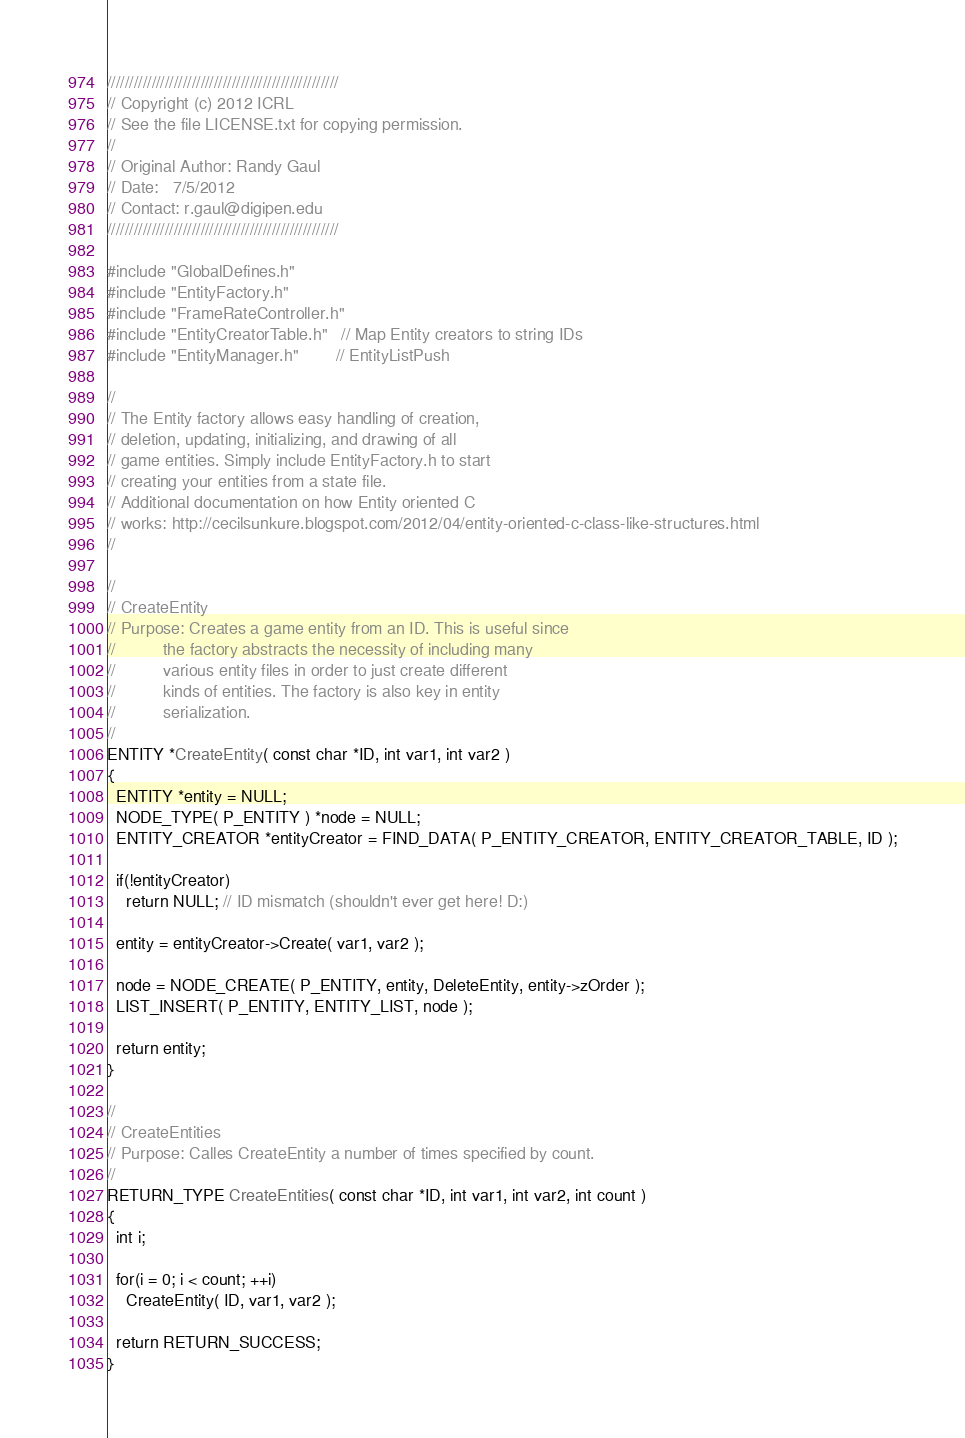Convert code to text. <code><loc_0><loc_0><loc_500><loc_500><_C_>////////////////////////////////////////////////////
// Copyright (c) 2012 ICRL
// See the file LICENSE.txt for copying permission.
// 
// Original Author: Randy Gaul
// Date:   7/5/2012
// Contact: r.gaul@digipen.edu
////////////////////////////////////////////////////

#include "GlobalDefines.h"
#include "EntityFactory.h"
#include "FrameRateController.h"
#include "EntityCreatorTable.h"   // Map Entity creators to string IDs
#include "EntityManager.h"        // EntityListPush

//
// The Entity factory allows easy handling of creation,
// deletion, updating, initializing, and drawing of all
// game entities. Simply include EntityFactory.h to start
// creating your entities from a state file.
// Additional documentation on how Entity oriented C
// works: http://cecilsunkure.blogspot.com/2012/04/entity-oriented-c-class-like-structures.html
//

//
// CreateEntity
// Purpose: Creates a game entity from an ID. This is useful since
//          the factory abstracts the necessity of including many
//          various entity files in order to just create different
//          kinds of entities. The factory is also key in entity
//          serialization.
//
ENTITY *CreateEntity( const char *ID, int var1, int var2 )
{
  ENTITY *entity = NULL;
  NODE_TYPE( P_ENTITY ) *node = NULL;
  ENTITY_CREATOR *entityCreator = FIND_DATA( P_ENTITY_CREATOR, ENTITY_CREATOR_TABLE, ID );

  if(!entityCreator)
    return NULL; // ID mismatch (shouldn't ever get here! D:)

  entity = entityCreator->Create( var1, var2 );

  node = NODE_CREATE( P_ENTITY, entity, DeleteEntity, entity->zOrder );
  LIST_INSERT( P_ENTITY, ENTITY_LIST, node );

  return entity;
}

//
// CreateEntities
// Purpose: Calles CreateEntity a number of times specified by count.
//
RETURN_TYPE CreateEntities( const char *ID, int var1, int var2, int count )
{
  int i;

  for(i = 0; i < count; ++i)
    CreateEntity( ID, var1, var2 );

  return RETURN_SUCCESS;
}
</code> 